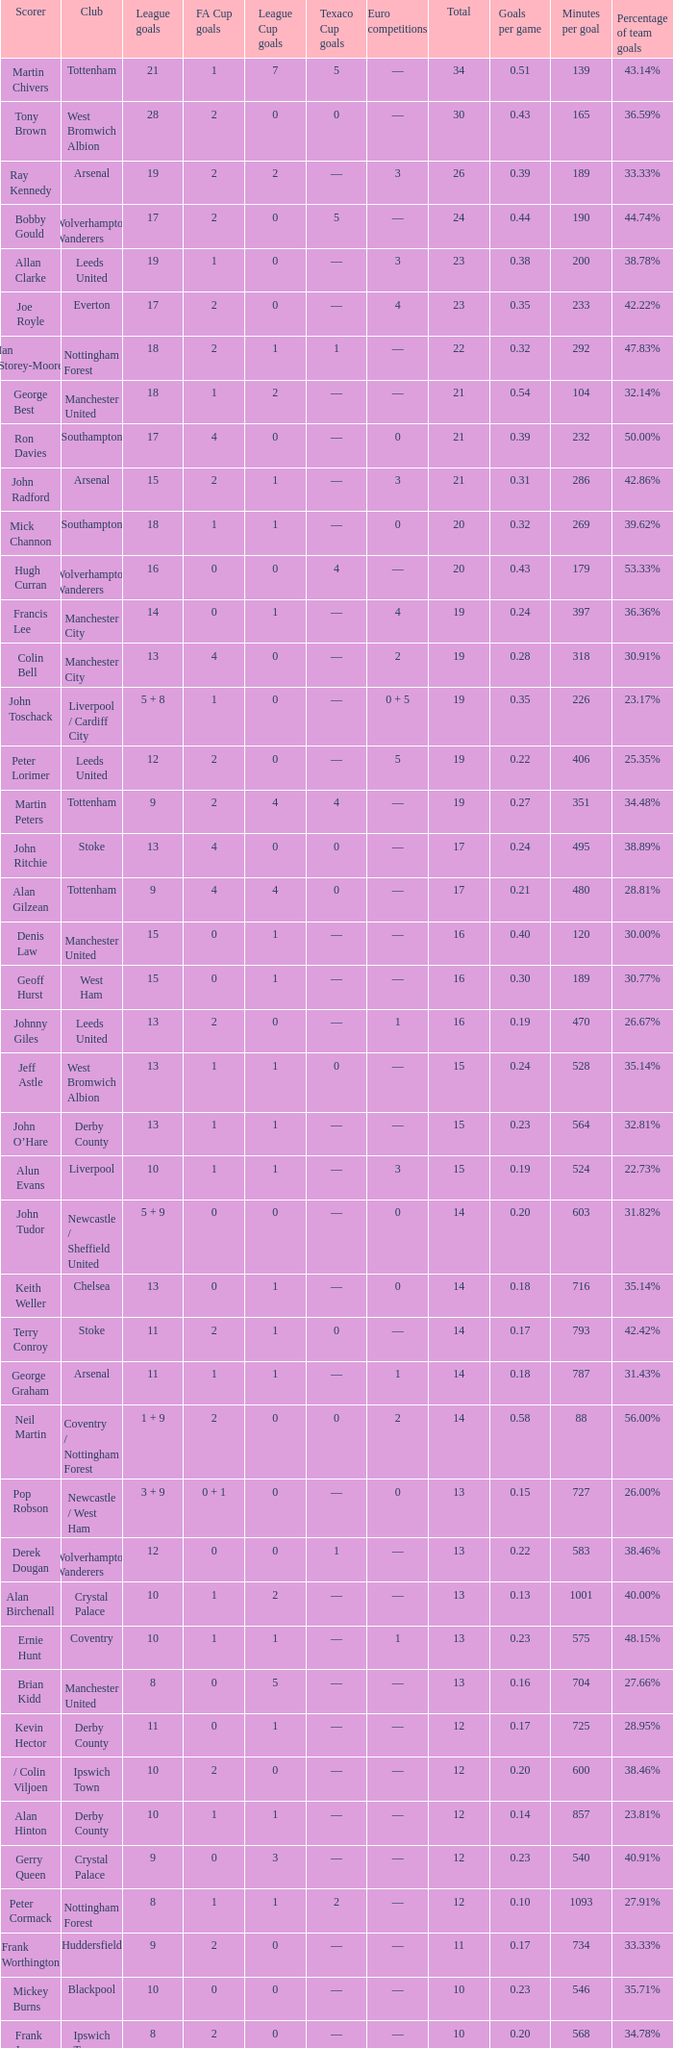What is the lowest League Cup Goals, when Scorer is Denis Law? 1.0. 